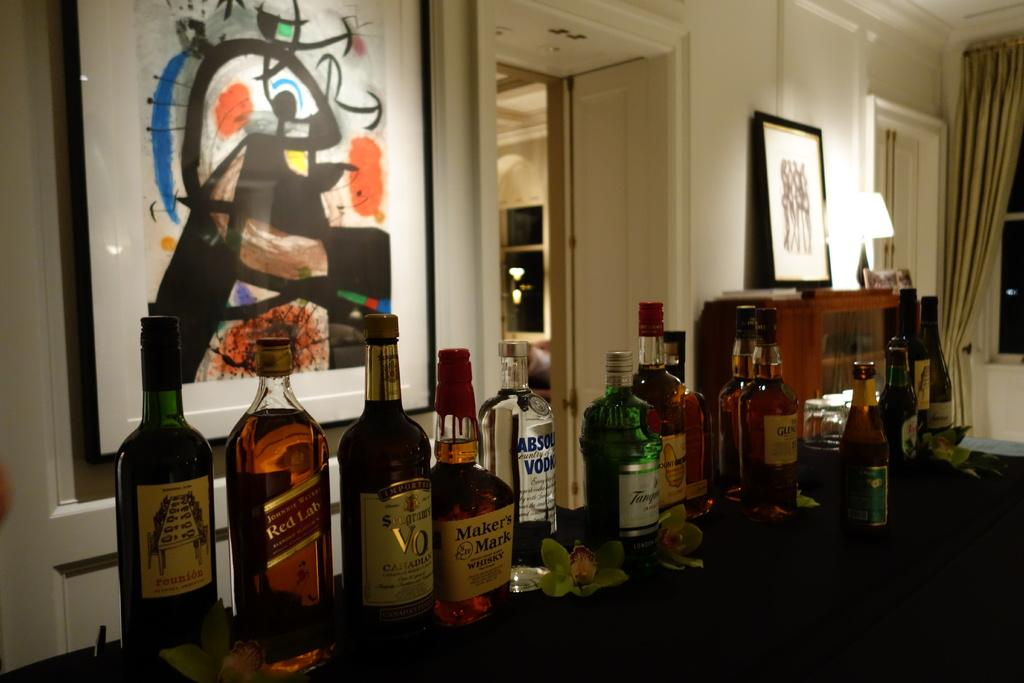<image>
Render a clear and concise summary of the photo. Quite a few bottles of alchohol including one called Makers Mark, are lined up on a table. 